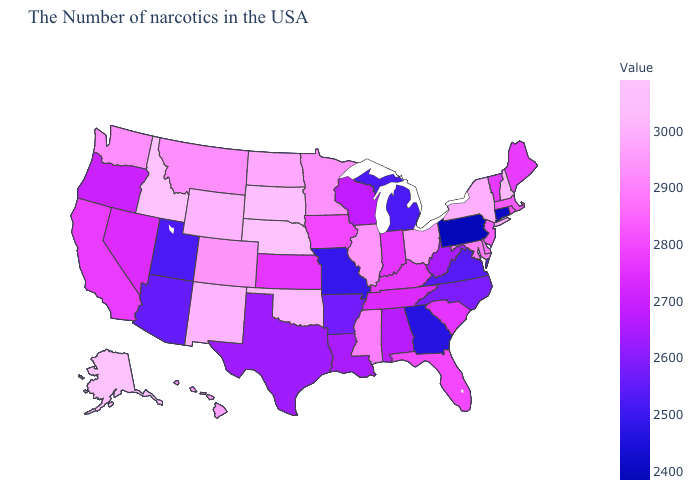Among the states that border Pennsylvania , does Maryland have the highest value?
Write a very short answer. No. Is the legend a continuous bar?
Keep it brief. Yes. Which states have the lowest value in the USA?
Short answer required. Pennsylvania. Which states have the lowest value in the USA?
Quick response, please. Pennsylvania. Does Illinois have a higher value than Oklahoma?
Quick response, please. No. Which states have the lowest value in the USA?
Be succinct. Pennsylvania. Which states hav the highest value in the MidWest?
Quick response, please. Nebraska. 